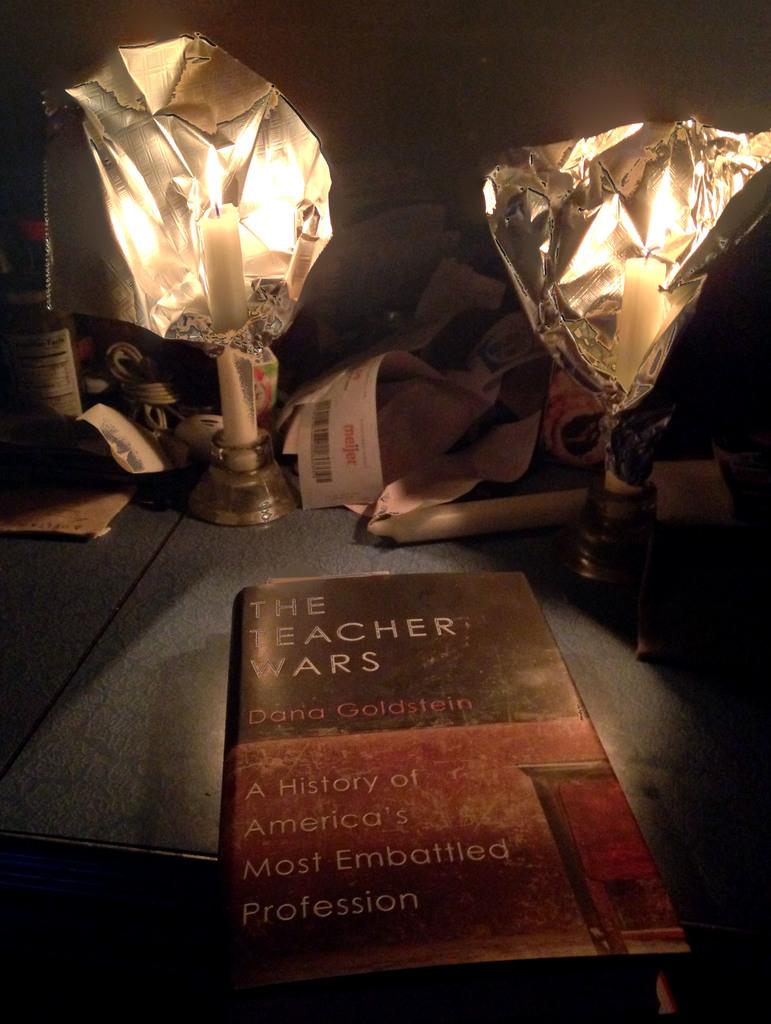What profession is the subject of the book depicted here?
Make the answer very short. Teacher. What is the title of this book?
Make the answer very short. The teacher wars. 